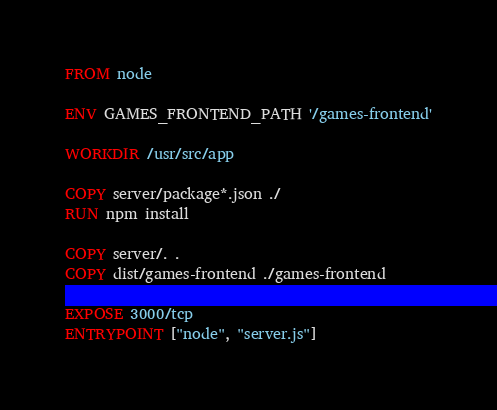<code> <loc_0><loc_0><loc_500><loc_500><_Dockerfile_>FROM node

ENV GAMES_FRONTEND_PATH '/games-frontend'

WORKDIR /usr/src/app

COPY server/package*.json ./
RUN npm install

COPY server/. .
COPY dist/games-frontend ./games-frontend

EXPOSE 3000/tcp
ENTRYPOINT ["node", "server.js"]
</code> 